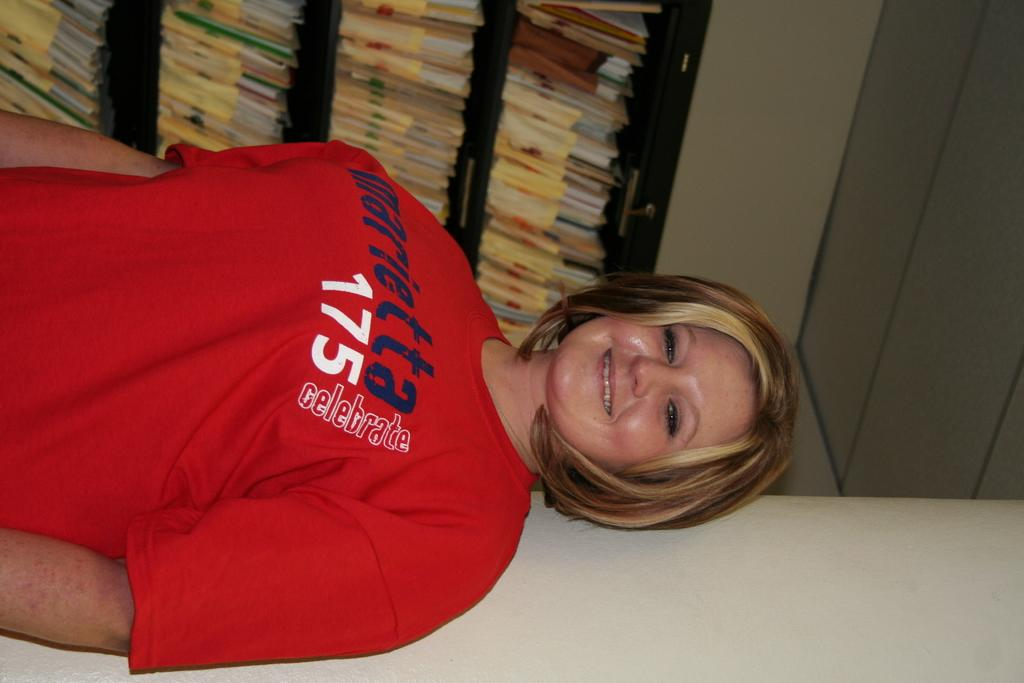<image>
Summarize the visual content of the image. A woman in a red t shirt with the digit 175. 